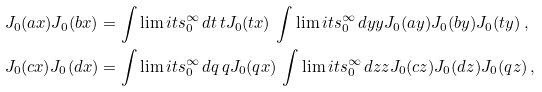Convert formula to latex. <formula><loc_0><loc_0><loc_500><loc_500>J _ { 0 } ( a x ) J _ { 0 } ( b x ) & = \int \lim i t s _ { 0 } ^ { \infty } \, d t \, t J _ { 0 } ( t x ) \, \int \lim i t s _ { 0 } ^ { \infty } \, d y y J _ { 0 } ( a y ) J _ { 0 } ( b y ) J _ { 0 } ( t y ) \, , \\ J _ { 0 } ( c x ) J _ { 0 } ( d x ) & = \int \lim i t s _ { 0 } ^ { \infty } \, d q \, q J _ { 0 } ( q x ) \, \int \lim i t s _ { 0 } ^ { \infty } \, d z z J _ { 0 } ( c z ) J _ { 0 } ( d z ) J _ { 0 } ( q z ) \, ,</formula> 